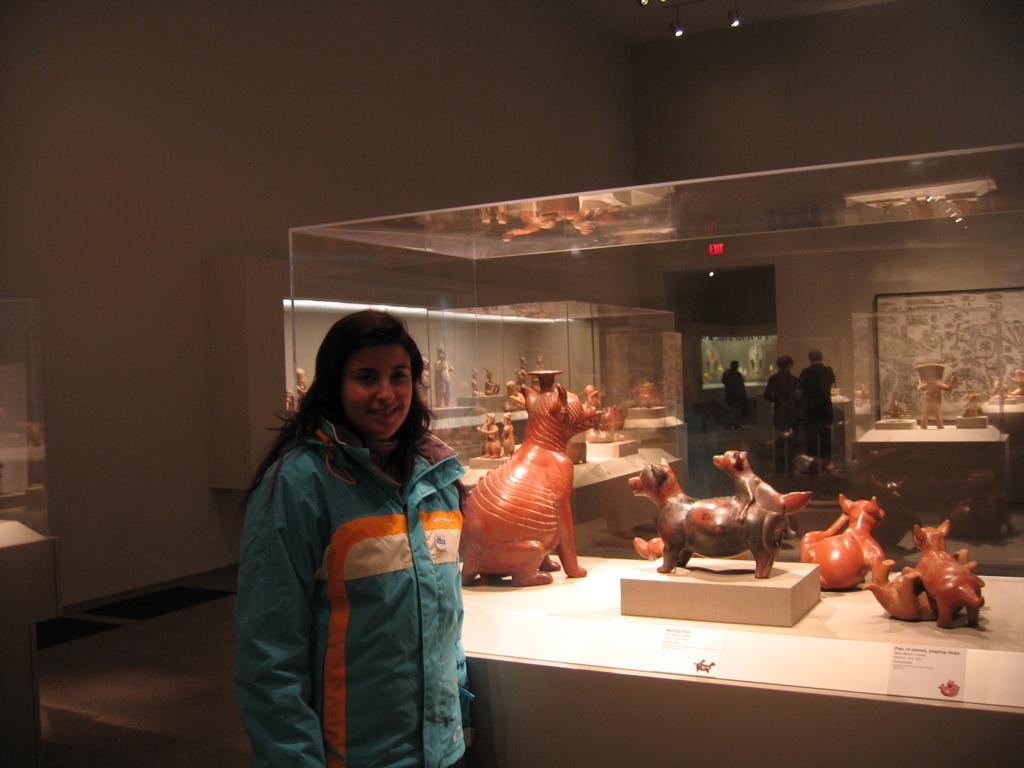Where was the image taken? The image was taken in a museum. What can be seen near the woman in the image? There is a table with toys beside the woman. How many people are visible in the background of the image? There are three persons visible in the background. What is the background of the image like? There is a plain wall in the background. What type of baseball equipment can be seen in the woman's pocket in the image? There is no baseball equipment or pocket visible in the image. What is the emotional state of the woman's heart in the image? The image does not provide information about the woman's emotional state or her heart. 